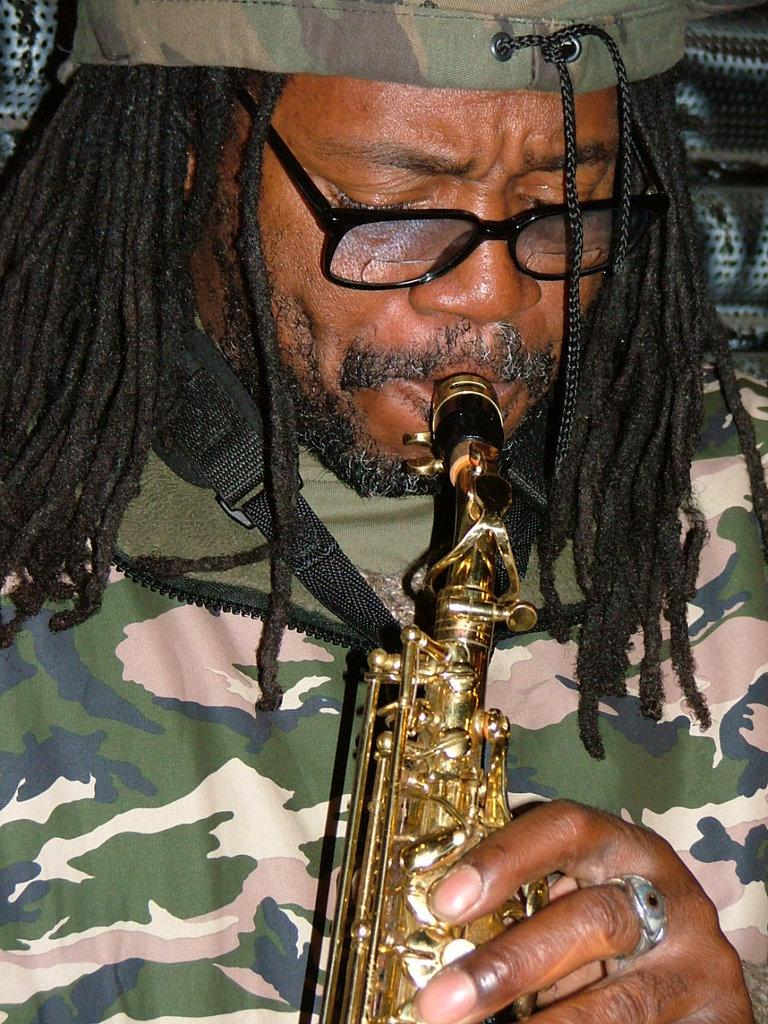What is the main subject of the image? There is a person in the image. What is the person holding in the image? The person is holding an instrument. Where is the person located in the image? The person is in the middle of the image. What type of skin can be seen on the hill in the image? There is no hill or skin present in the image; it features a person holding an instrument. 